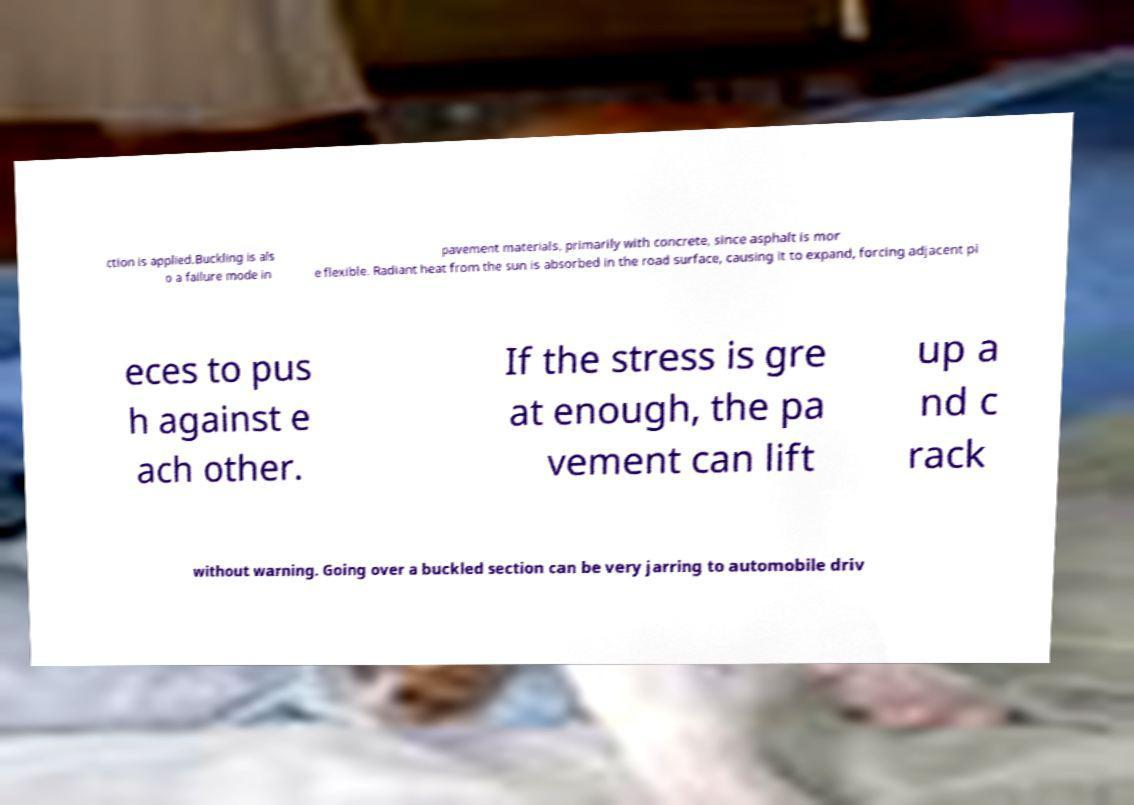Please read and relay the text visible in this image. What does it say? ction is applied.Buckling is als o a failure mode in pavement materials, primarily with concrete, since asphalt is mor e flexible. Radiant heat from the sun is absorbed in the road surface, causing it to expand, forcing adjacent pi eces to pus h against e ach other. If the stress is gre at enough, the pa vement can lift up a nd c rack without warning. Going over a buckled section can be very jarring to automobile driv 